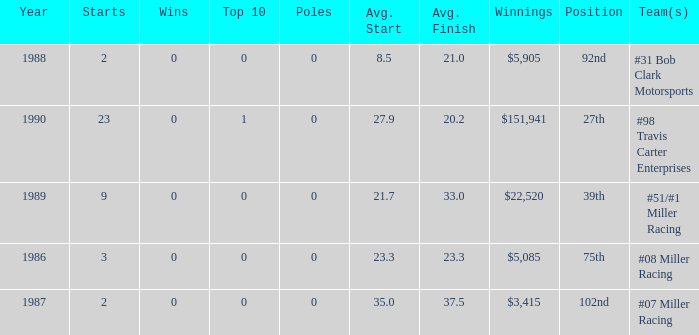How many teams finished in the top team with an average finish of 23.3? 1.0. 